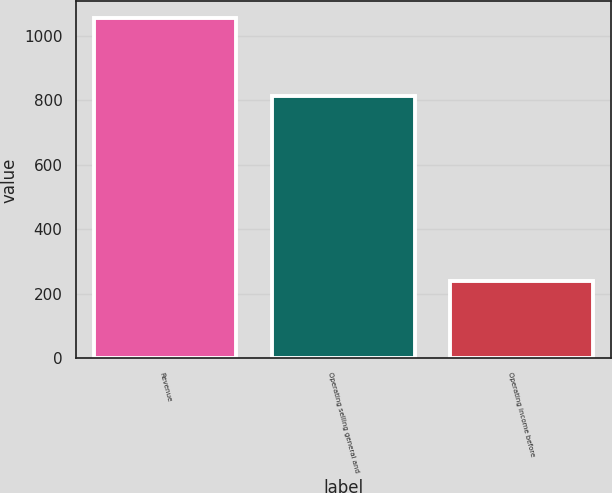Convert chart. <chart><loc_0><loc_0><loc_500><loc_500><bar_chart><fcel>Revenue<fcel>Operating selling general and<fcel>Operating income before<nl><fcel>1054<fcel>815<fcel>239<nl></chart> 